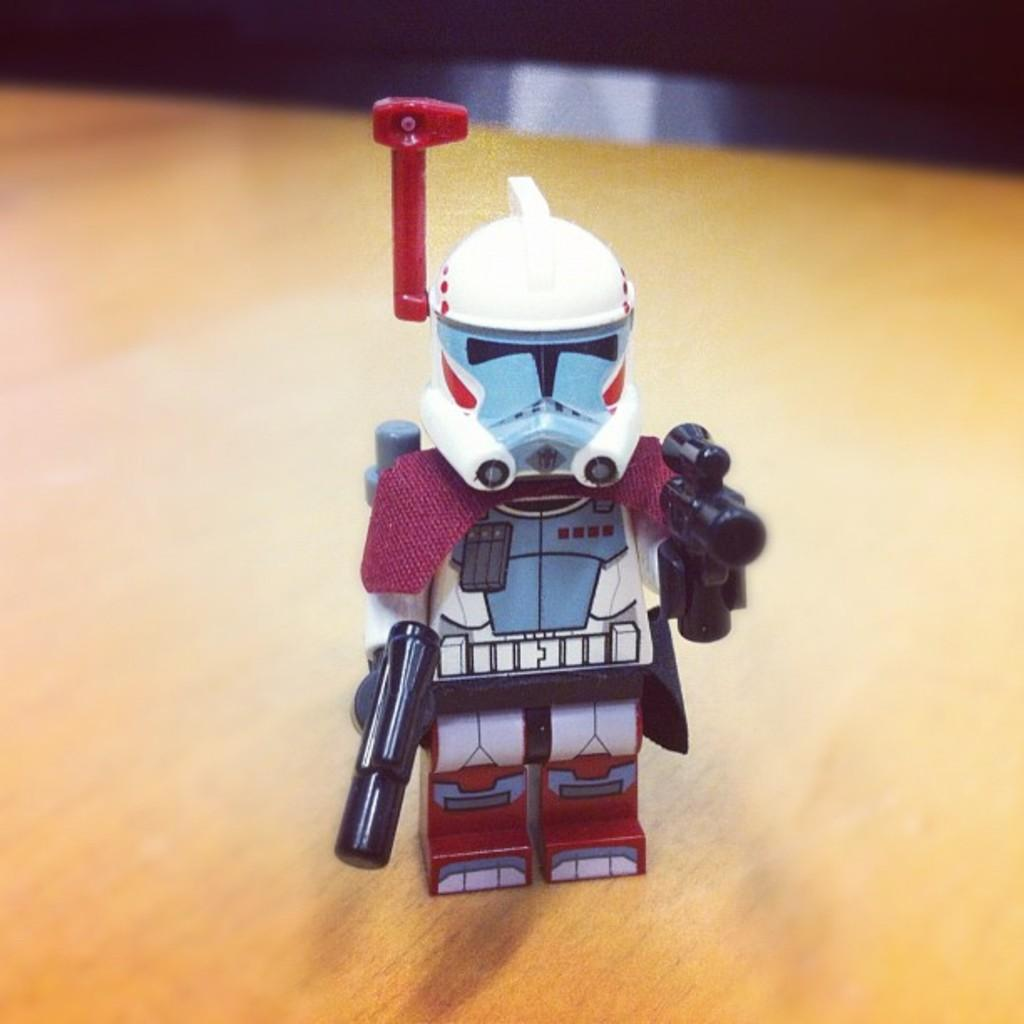What object can be seen in the image? There is a toy in the image. On what type of surface is the toy placed? The toy is on a wooden surface. Can you describe the background of the image? The background of the image is blurry. What type of development can be seen in the background of the image? There is no development visible in the background of the image, as it is blurry. Can you see a cat playing with the toy in the image? There is no cat present in the image; it only features a toy on a wooden surface. 